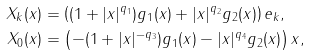Convert formula to latex. <formula><loc_0><loc_0><loc_500><loc_500>X _ { k } ( x ) & = \left ( ( 1 + | x | ^ { q _ { 1 } } ) g _ { 1 } ( x ) + | x | ^ { q _ { 2 } } g _ { 2 } ( x ) \right ) e _ { k } , \\ X _ { 0 } ( x ) & = \left ( - ( 1 + | x | ^ { - q _ { 3 } } ) g _ { 1 } ( x ) - | x | ^ { q _ { 4 } } g _ { 2 } ( x ) \right ) x ,</formula> 